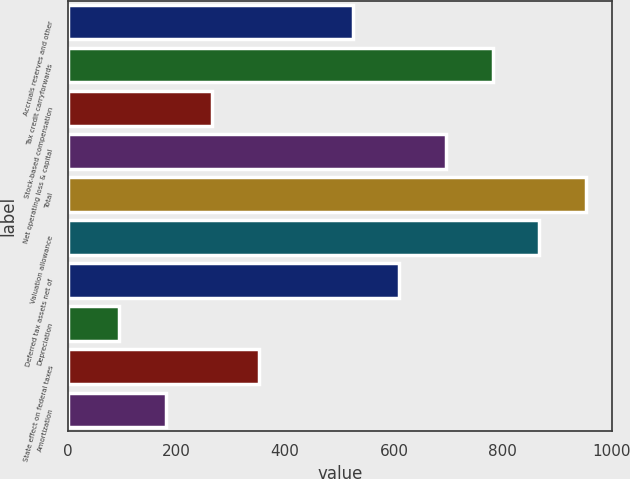<chart> <loc_0><loc_0><loc_500><loc_500><bar_chart><fcel>Accruals reserves and other<fcel>Tax credit carryforwards<fcel>Stock-based compensation<fcel>Net operating loss & capital<fcel>Total<fcel>Valuation allowance<fcel>Deferred tax assets net of<fcel>Depreciation<fcel>State effect on federal taxes<fcel>Amortization<nl><fcel>523.8<fcel>781.2<fcel>266.4<fcel>695.4<fcel>952.8<fcel>867<fcel>609.6<fcel>94.8<fcel>352.2<fcel>180.6<nl></chart> 